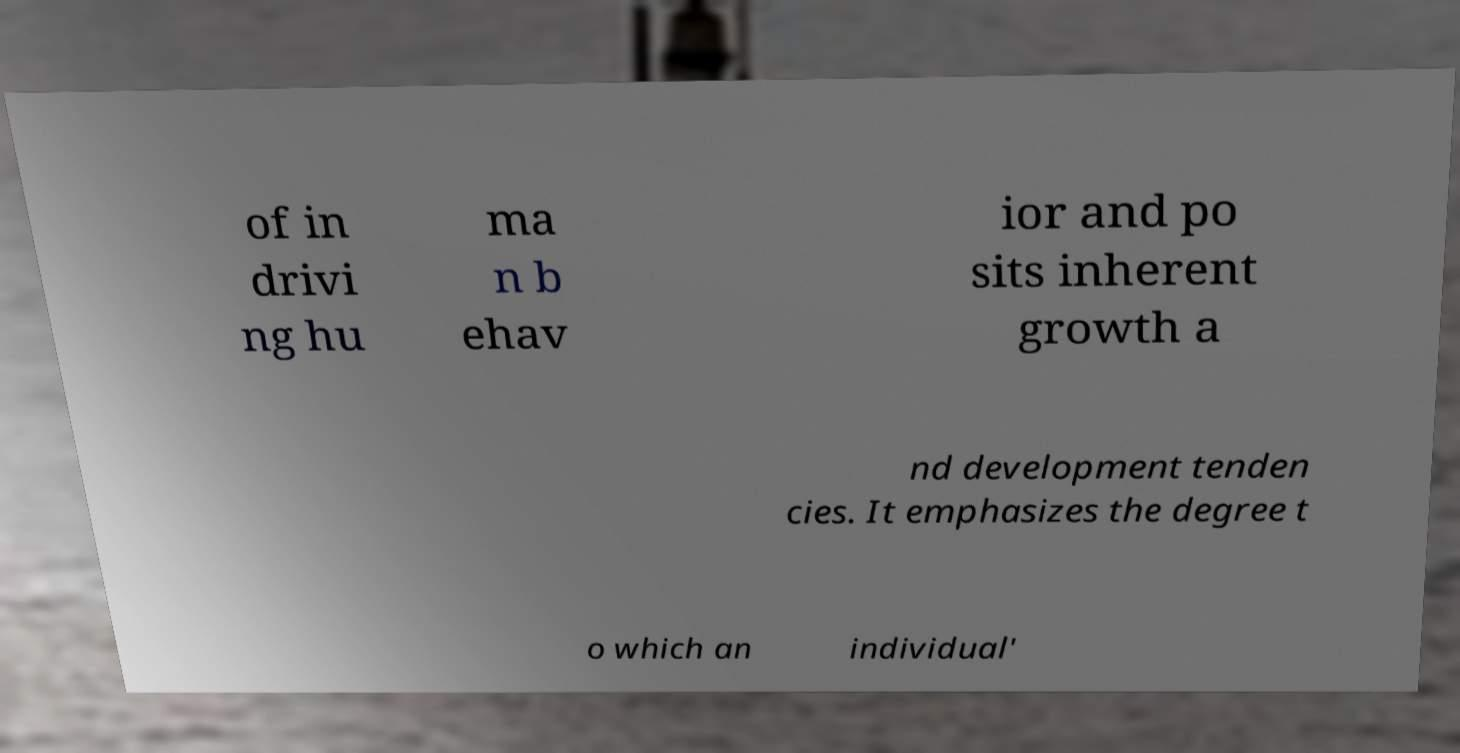Could you extract and type out the text from this image? of in drivi ng hu ma n b ehav ior and po sits inherent growth a nd development tenden cies. It emphasizes the degree t o which an individual' 